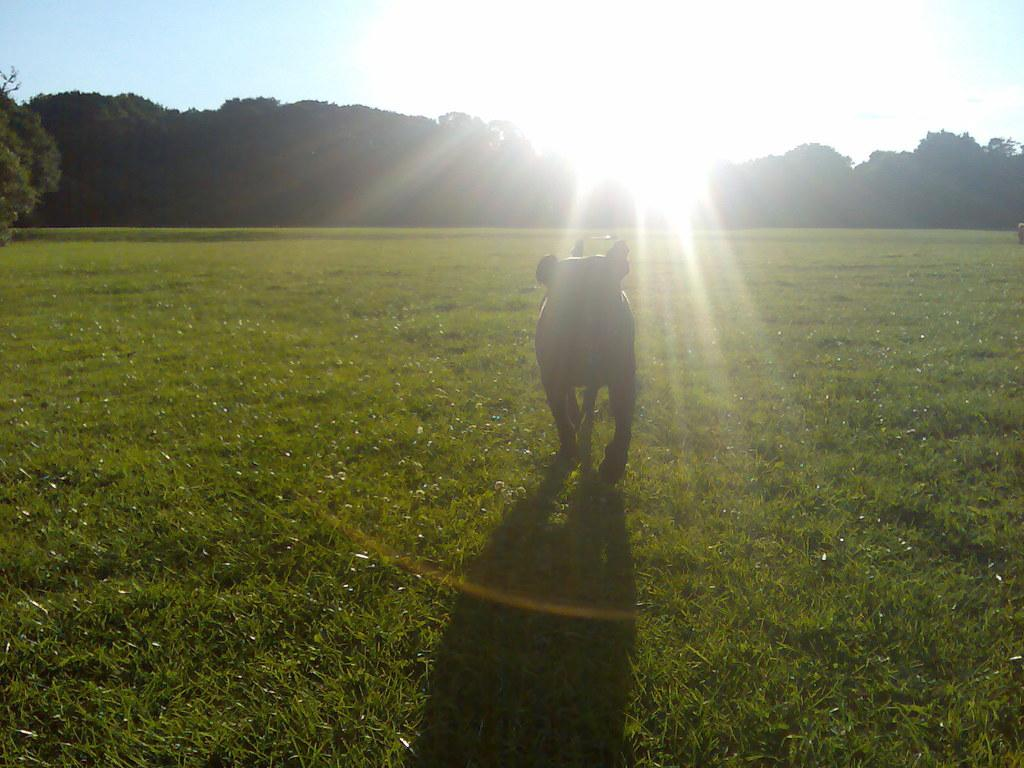What animal can be seen in the image? There is a dog in the image. What is the dog doing in the image? The dog is walking on the grass. What can be seen in the background of the image? There are trees in the background of the image. What type of hammer is the dog using to compete in the image? There is no hammer or competition present in the image; it features a dog walking on the grass with trees in the background. 